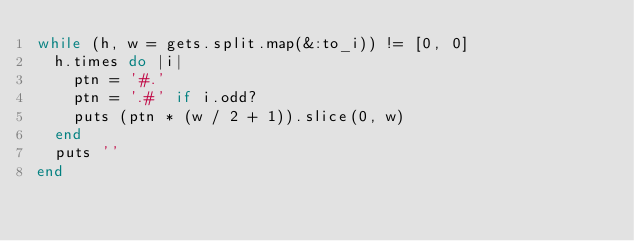Convert code to text. <code><loc_0><loc_0><loc_500><loc_500><_Ruby_>while (h, w = gets.split.map(&:to_i)) != [0, 0]
  h.times do |i|
    ptn = '#.'
    ptn = '.#' if i.odd?
    puts (ptn * (w / 2 + 1)).slice(0, w)
  end
  puts ''
end

</code> 